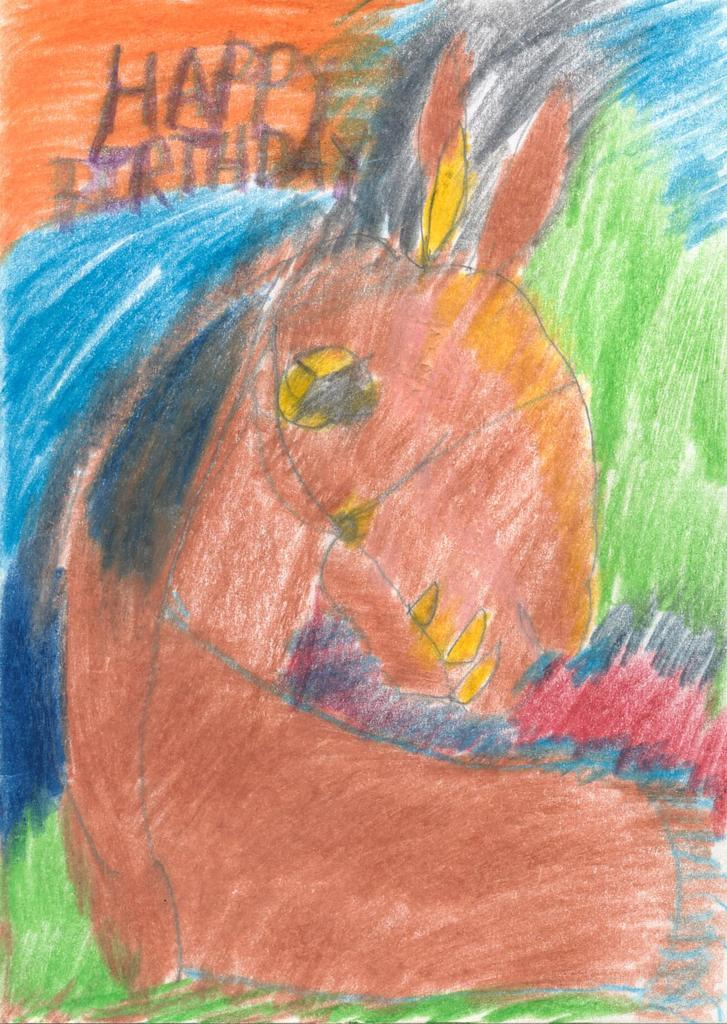What is depicted in the image related to animals? There is a drawing or photo of a brown horse in the image. What type of artwork can be seen in the image? There is a blue and green color crayon painting in the image. What message is written at the top of the image? The words "Happy Birthday" are written at the top of the image. How many rings are visible on the brown horse's legs in the image? There are no rings visible on the brown horse's legs in the image, as it is a drawing or photo and not a real horse. 